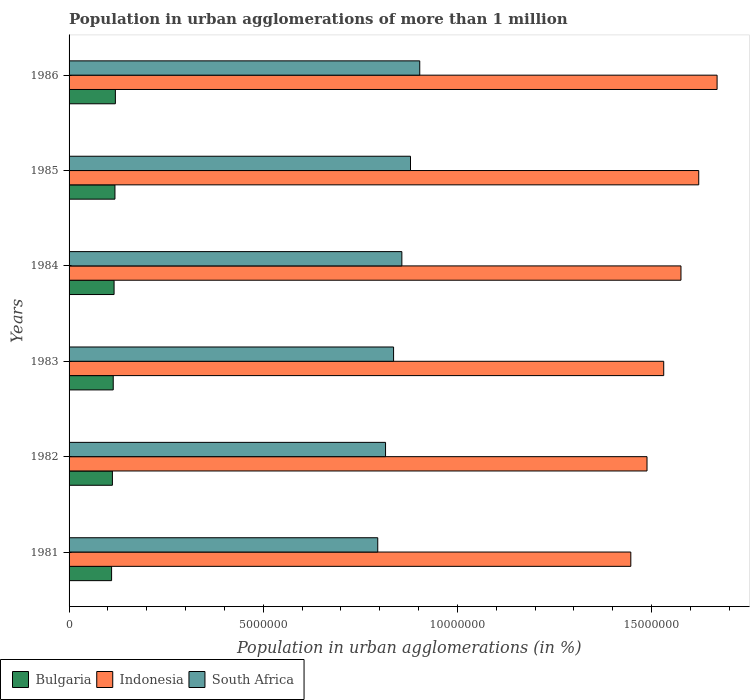How many different coloured bars are there?
Give a very brief answer. 3. Are the number of bars per tick equal to the number of legend labels?
Your answer should be compact. Yes. How many bars are there on the 1st tick from the top?
Ensure brevity in your answer.  3. What is the label of the 1st group of bars from the top?
Make the answer very short. 1986. In how many cases, is the number of bars for a given year not equal to the number of legend labels?
Provide a succinct answer. 0. What is the population in urban agglomerations in South Africa in 1982?
Offer a very short reply. 8.15e+06. Across all years, what is the maximum population in urban agglomerations in Indonesia?
Your answer should be compact. 1.67e+07. Across all years, what is the minimum population in urban agglomerations in South Africa?
Provide a short and direct response. 7.95e+06. In which year was the population in urban agglomerations in South Africa maximum?
Make the answer very short. 1986. In which year was the population in urban agglomerations in Indonesia minimum?
Offer a terse response. 1981. What is the total population in urban agglomerations in Bulgaria in the graph?
Provide a short and direct response. 6.88e+06. What is the difference between the population in urban agglomerations in South Africa in 1985 and that in 1986?
Provide a succinct answer. -2.38e+05. What is the difference between the population in urban agglomerations in South Africa in 1985 and the population in urban agglomerations in Indonesia in 1984?
Keep it short and to the point. -6.97e+06. What is the average population in urban agglomerations in South Africa per year?
Provide a succinct answer. 8.48e+06. In the year 1981, what is the difference between the population in urban agglomerations in Indonesia and population in urban agglomerations in South Africa?
Your answer should be very brief. 6.52e+06. What is the ratio of the population in urban agglomerations in Indonesia in 1982 to that in 1985?
Your answer should be compact. 0.92. Is the population in urban agglomerations in Bulgaria in 1982 less than that in 1984?
Provide a succinct answer. Yes. What is the difference between the highest and the second highest population in urban agglomerations in Indonesia?
Offer a very short reply. 4.73e+05. What is the difference between the highest and the lowest population in urban agglomerations in Bulgaria?
Your response must be concise. 9.76e+04. What does the 1st bar from the bottom in 1983 represents?
Offer a terse response. Bulgaria. Is it the case that in every year, the sum of the population in urban agglomerations in Indonesia and population in urban agglomerations in Bulgaria is greater than the population in urban agglomerations in South Africa?
Your answer should be compact. Yes. How many years are there in the graph?
Provide a succinct answer. 6. Are the values on the major ticks of X-axis written in scientific E-notation?
Ensure brevity in your answer.  No. Does the graph contain any zero values?
Make the answer very short. No. Where does the legend appear in the graph?
Provide a short and direct response. Bottom left. How many legend labels are there?
Offer a very short reply. 3. What is the title of the graph?
Provide a short and direct response. Population in urban agglomerations of more than 1 million. What is the label or title of the X-axis?
Provide a succinct answer. Population in urban agglomerations (in %). What is the Population in urban agglomerations (in %) in Bulgaria in 1981?
Your answer should be compact. 1.09e+06. What is the Population in urban agglomerations (in %) in Indonesia in 1981?
Provide a short and direct response. 1.45e+07. What is the Population in urban agglomerations (in %) of South Africa in 1981?
Your answer should be compact. 7.95e+06. What is the Population in urban agglomerations (in %) of Bulgaria in 1982?
Make the answer very short. 1.12e+06. What is the Population in urban agglomerations (in %) in Indonesia in 1982?
Offer a terse response. 1.49e+07. What is the Population in urban agglomerations (in %) of South Africa in 1982?
Offer a terse response. 8.15e+06. What is the Population in urban agglomerations (in %) of Bulgaria in 1983?
Ensure brevity in your answer.  1.14e+06. What is the Population in urban agglomerations (in %) of Indonesia in 1983?
Your answer should be compact. 1.53e+07. What is the Population in urban agglomerations (in %) of South Africa in 1983?
Give a very brief answer. 8.36e+06. What is the Population in urban agglomerations (in %) in Bulgaria in 1984?
Your answer should be compact. 1.16e+06. What is the Population in urban agglomerations (in %) of Indonesia in 1984?
Provide a succinct answer. 1.58e+07. What is the Population in urban agglomerations (in %) in South Africa in 1984?
Ensure brevity in your answer.  8.57e+06. What is the Population in urban agglomerations (in %) of Bulgaria in 1985?
Provide a short and direct response. 1.18e+06. What is the Population in urban agglomerations (in %) of Indonesia in 1985?
Offer a terse response. 1.62e+07. What is the Population in urban agglomerations (in %) of South Africa in 1985?
Give a very brief answer. 8.79e+06. What is the Population in urban agglomerations (in %) in Bulgaria in 1986?
Provide a short and direct response. 1.19e+06. What is the Population in urban agglomerations (in %) of Indonesia in 1986?
Make the answer very short. 1.67e+07. What is the Population in urban agglomerations (in %) in South Africa in 1986?
Your answer should be very brief. 9.03e+06. Across all years, what is the maximum Population in urban agglomerations (in %) in Bulgaria?
Provide a succinct answer. 1.19e+06. Across all years, what is the maximum Population in urban agglomerations (in %) of Indonesia?
Give a very brief answer. 1.67e+07. Across all years, what is the maximum Population in urban agglomerations (in %) of South Africa?
Keep it short and to the point. 9.03e+06. Across all years, what is the minimum Population in urban agglomerations (in %) of Bulgaria?
Make the answer very short. 1.09e+06. Across all years, what is the minimum Population in urban agglomerations (in %) in Indonesia?
Ensure brevity in your answer.  1.45e+07. Across all years, what is the minimum Population in urban agglomerations (in %) in South Africa?
Your answer should be compact. 7.95e+06. What is the total Population in urban agglomerations (in %) of Bulgaria in the graph?
Keep it short and to the point. 6.88e+06. What is the total Population in urban agglomerations (in %) in Indonesia in the graph?
Keep it short and to the point. 9.33e+07. What is the total Population in urban agglomerations (in %) of South Africa in the graph?
Give a very brief answer. 5.09e+07. What is the difference between the Population in urban agglomerations (in %) in Bulgaria in 1981 and that in 1982?
Keep it short and to the point. -2.10e+04. What is the difference between the Population in urban agglomerations (in %) of Indonesia in 1981 and that in 1982?
Make the answer very short. -4.17e+05. What is the difference between the Population in urban agglomerations (in %) in South Africa in 1981 and that in 1982?
Give a very brief answer. -2.01e+05. What is the difference between the Population in urban agglomerations (in %) in Bulgaria in 1981 and that in 1983?
Ensure brevity in your answer.  -4.24e+04. What is the difference between the Population in urban agglomerations (in %) in Indonesia in 1981 and that in 1983?
Provide a succinct answer. -8.47e+05. What is the difference between the Population in urban agglomerations (in %) of South Africa in 1981 and that in 1983?
Provide a short and direct response. -4.08e+05. What is the difference between the Population in urban agglomerations (in %) of Bulgaria in 1981 and that in 1984?
Offer a terse response. -6.43e+04. What is the difference between the Population in urban agglomerations (in %) in Indonesia in 1981 and that in 1984?
Provide a succinct answer. -1.29e+06. What is the difference between the Population in urban agglomerations (in %) of South Africa in 1981 and that in 1984?
Your response must be concise. -6.21e+05. What is the difference between the Population in urban agglomerations (in %) of Bulgaria in 1981 and that in 1985?
Provide a succinct answer. -8.65e+04. What is the difference between the Population in urban agglomerations (in %) in Indonesia in 1981 and that in 1985?
Provide a succinct answer. -1.75e+06. What is the difference between the Population in urban agglomerations (in %) of South Africa in 1981 and that in 1985?
Give a very brief answer. -8.44e+05. What is the difference between the Population in urban agglomerations (in %) of Bulgaria in 1981 and that in 1986?
Your response must be concise. -9.76e+04. What is the difference between the Population in urban agglomerations (in %) of Indonesia in 1981 and that in 1986?
Ensure brevity in your answer.  -2.22e+06. What is the difference between the Population in urban agglomerations (in %) of South Africa in 1981 and that in 1986?
Your answer should be very brief. -1.08e+06. What is the difference between the Population in urban agglomerations (in %) of Bulgaria in 1982 and that in 1983?
Give a very brief answer. -2.14e+04. What is the difference between the Population in urban agglomerations (in %) of Indonesia in 1982 and that in 1983?
Give a very brief answer. -4.30e+05. What is the difference between the Population in urban agglomerations (in %) in South Africa in 1982 and that in 1983?
Provide a succinct answer. -2.07e+05. What is the difference between the Population in urban agglomerations (in %) of Bulgaria in 1982 and that in 1984?
Your response must be concise. -4.33e+04. What is the difference between the Population in urban agglomerations (in %) in Indonesia in 1982 and that in 1984?
Keep it short and to the point. -8.75e+05. What is the difference between the Population in urban agglomerations (in %) of South Africa in 1982 and that in 1984?
Provide a succinct answer. -4.20e+05. What is the difference between the Population in urban agglomerations (in %) of Bulgaria in 1982 and that in 1985?
Keep it short and to the point. -6.55e+04. What is the difference between the Population in urban agglomerations (in %) of Indonesia in 1982 and that in 1985?
Your answer should be very brief. -1.33e+06. What is the difference between the Population in urban agglomerations (in %) in South Africa in 1982 and that in 1985?
Make the answer very short. -6.43e+05. What is the difference between the Population in urban agglomerations (in %) in Bulgaria in 1982 and that in 1986?
Offer a very short reply. -7.66e+04. What is the difference between the Population in urban agglomerations (in %) of Indonesia in 1982 and that in 1986?
Your answer should be compact. -1.80e+06. What is the difference between the Population in urban agglomerations (in %) in South Africa in 1982 and that in 1986?
Your answer should be compact. -8.81e+05. What is the difference between the Population in urban agglomerations (in %) in Bulgaria in 1983 and that in 1984?
Make the answer very short. -2.19e+04. What is the difference between the Population in urban agglomerations (in %) in Indonesia in 1983 and that in 1984?
Make the answer very short. -4.45e+05. What is the difference between the Population in urban agglomerations (in %) of South Africa in 1983 and that in 1984?
Provide a succinct answer. -2.13e+05. What is the difference between the Population in urban agglomerations (in %) in Bulgaria in 1983 and that in 1985?
Provide a succinct answer. -4.41e+04. What is the difference between the Population in urban agglomerations (in %) of Indonesia in 1983 and that in 1985?
Ensure brevity in your answer.  -9.02e+05. What is the difference between the Population in urban agglomerations (in %) of South Africa in 1983 and that in 1985?
Provide a succinct answer. -4.36e+05. What is the difference between the Population in urban agglomerations (in %) in Bulgaria in 1983 and that in 1986?
Your answer should be compact. -5.51e+04. What is the difference between the Population in urban agglomerations (in %) in Indonesia in 1983 and that in 1986?
Provide a succinct answer. -1.37e+06. What is the difference between the Population in urban agglomerations (in %) in South Africa in 1983 and that in 1986?
Offer a terse response. -6.74e+05. What is the difference between the Population in urban agglomerations (in %) in Bulgaria in 1984 and that in 1985?
Ensure brevity in your answer.  -2.22e+04. What is the difference between the Population in urban agglomerations (in %) in Indonesia in 1984 and that in 1985?
Your answer should be very brief. -4.57e+05. What is the difference between the Population in urban agglomerations (in %) in South Africa in 1984 and that in 1985?
Your response must be concise. -2.23e+05. What is the difference between the Population in urban agglomerations (in %) of Bulgaria in 1984 and that in 1986?
Make the answer very short. -3.33e+04. What is the difference between the Population in urban agglomerations (in %) in Indonesia in 1984 and that in 1986?
Give a very brief answer. -9.30e+05. What is the difference between the Population in urban agglomerations (in %) in South Africa in 1984 and that in 1986?
Make the answer very short. -4.61e+05. What is the difference between the Population in urban agglomerations (in %) in Bulgaria in 1985 and that in 1986?
Give a very brief answer. -1.11e+04. What is the difference between the Population in urban agglomerations (in %) of Indonesia in 1985 and that in 1986?
Your response must be concise. -4.73e+05. What is the difference between the Population in urban agglomerations (in %) in South Africa in 1985 and that in 1986?
Ensure brevity in your answer.  -2.38e+05. What is the difference between the Population in urban agglomerations (in %) of Bulgaria in 1981 and the Population in urban agglomerations (in %) of Indonesia in 1982?
Offer a terse response. -1.38e+07. What is the difference between the Population in urban agglomerations (in %) in Bulgaria in 1981 and the Population in urban agglomerations (in %) in South Africa in 1982?
Offer a very short reply. -7.06e+06. What is the difference between the Population in urban agglomerations (in %) in Indonesia in 1981 and the Population in urban agglomerations (in %) in South Africa in 1982?
Give a very brief answer. 6.32e+06. What is the difference between the Population in urban agglomerations (in %) of Bulgaria in 1981 and the Population in urban agglomerations (in %) of Indonesia in 1983?
Ensure brevity in your answer.  -1.42e+07. What is the difference between the Population in urban agglomerations (in %) of Bulgaria in 1981 and the Population in urban agglomerations (in %) of South Africa in 1983?
Your answer should be very brief. -7.26e+06. What is the difference between the Population in urban agglomerations (in %) in Indonesia in 1981 and the Population in urban agglomerations (in %) in South Africa in 1983?
Your answer should be very brief. 6.11e+06. What is the difference between the Population in urban agglomerations (in %) in Bulgaria in 1981 and the Population in urban agglomerations (in %) in Indonesia in 1984?
Provide a short and direct response. -1.47e+07. What is the difference between the Population in urban agglomerations (in %) of Bulgaria in 1981 and the Population in urban agglomerations (in %) of South Africa in 1984?
Offer a very short reply. -7.48e+06. What is the difference between the Population in urban agglomerations (in %) of Indonesia in 1981 and the Population in urban agglomerations (in %) of South Africa in 1984?
Your answer should be compact. 5.90e+06. What is the difference between the Population in urban agglomerations (in %) in Bulgaria in 1981 and the Population in urban agglomerations (in %) in Indonesia in 1985?
Make the answer very short. -1.51e+07. What is the difference between the Population in urban agglomerations (in %) of Bulgaria in 1981 and the Population in urban agglomerations (in %) of South Africa in 1985?
Give a very brief answer. -7.70e+06. What is the difference between the Population in urban agglomerations (in %) in Indonesia in 1981 and the Population in urban agglomerations (in %) in South Africa in 1985?
Your answer should be very brief. 5.67e+06. What is the difference between the Population in urban agglomerations (in %) of Bulgaria in 1981 and the Population in urban agglomerations (in %) of Indonesia in 1986?
Offer a terse response. -1.56e+07. What is the difference between the Population in urban agglomerations (in %) of Bulgaria in 1981 and the Population in urban agglomerations (in %) of South Africa in 1986?
Your response must be concise. -7.94e+06. What is the difference between the Population in urban agglomerations (in %) of Indonesia in 1981 and the Population in urban agglomerations (in %) of South Africa in 1986?
Offer a terse response. 5.44e+06. What is the difference between the Population in urban agglomerations (in %) of Bulgaria in 1982 and the Population in urban agglomerations (in %) of Indonesia in 1983?
Ensure brevity in your answer.  -1.42e+07. What is the difference between the Population in urban agglomerations (in %) in Bulgaria in 1982 and the Population in urban agglomerations (in %) in South Africa in 1983?
Provide a short and direct response. -7.24e+06. What is the difference between the Population in urban agglomerations (in %) in Indonesia in 1982 and the Population in urban agglomerations (in %) in South Africa in 1983?
Your answer should be very brief. 6.53e+06. What is the difference between the Population in urban agglomerations (in %) of Bulgaria in 1982 and the Population in urban agglomerations (in %) of Indonesia in 1984?
Make the answer very short. -1.46e+07. What is the difference between the Population in urban agglomerations (in %) of Bulgaria in 1982 and the Population in urban agglomerations (in %) of South Africa in 1984?
Provide a short and direct response. -7.45e+06. What is the difference between the Population in urban agglomerations (in %) of Indonesia in 1982 and the Population in urban agglomerations (in %) of South Africa in 1984?
Give a very brief answer. 6.31e+06. What is the difference between the Population in urban agglomerations (in %) of Bulgaria in 1982 and the Population in urban agglomerations (in %) of Indonesia in 1985?
Give a very brief answer. -1.51e+07. What is the difference between the Population in urban agglomerations (in %) in Bulgaria in 1982 and the Population in urban agglomerations (in %) in South Africa in 1985?
Give a very brief answer. -7.68e+06. What is the difference between the Population in urban agglomerations (in %) of Indonesia in 1982 and the Population in urban agglomerations (in %) of South Africa in 1985?
Keep it short and to the point. 6.09e+06. What is the difference between the Population in urban agglomerations (in %) in Bulgaria in 1982 and the Population in urban agglomerations (in %) in Indonesia in 1986?
Provide a short and direct response. -1.56e+07. What is the difference between the Population in urban agglomerations (in %) in Bulgaria in 1982 and the Population in urban agglomerations (in %) in South Africa in 1986?
Offer a very short reply. -7.92e+06. What is the difference between the Population in urban agglomerations (in %) of Indonesia in 1982 and the Population in urban agglomerations (in %) of South Africa in 1986?
Make the answer very short. 5.85e+06. What is the difference between the Population in urban agglomerations (in %) in Bulgaria in 1983 and the Population in urban agglomerations (in %) in Indonesia in 1984?
Your response must be concise. -1.46e+07. What is the difference between the Population in urban agglomerations (in %) in Bulgaria in 1983 and the Population in urban agglomerations (in %) in South Africa in 1984?
Your response must be concise. -7.43e+06. What is the difference between the Population in urban agglomerations (in %) of Indonesia in 1983 and the Population in urban agglomerations (in %) of South Africa in 1984?
Offer a very short reply. 6.74e+06. What is the difference between the Population in urban agglomerations (in %) in Bulgaria in 1983 and the Population in urban agglomerations (in %) in Indonesia in 1985?
Your answer should be very brief. -1.51e+07. What is the difference between the Population in urban agglomerations (in %) of Bulgaria in 1983 and the Population in urban agglomerations (in %) of South Africa in 1985?
Provide a succinct answer. -7.66e+06. What is the difference between the Population in urban agglomerations (in %) in Indonesia in 1983 and the Population in urban agglomerations (in %) in South Africa in 1985?
Your answer should be very brief. 6.52e+06. What is the difference between the Population in urban agglomerations (in %) in Bulgaria in 1983 and the Population in urban agglomerations (in %) in Indonesia in 1986?
Your answer should be very brief. -1.56e+07. What is the difference between the Population in urban agglomerations (in %) of Bulgaria in 1983 and the Population in urban agglomerations (in %) of South Africa in 1986?
Your answer should be compact. -7.89e+06. What is the difference between the Population in urban agglomerations (in %) of Indonesia in 1983 and the Population in urban agglomerations (in %) of South Africa in 1986?
Provide a short and direct response. 6.28e+06. What is the difference between the Population in urban agglomerations (in %) in Bulgaria in 1984 and the Population in urban agglomerations (in %) in Indonesia in 1985?
Make the answer very short. -1.51e+07. What is the difference between the Population in urban agglomerations (in %) of Bulgaria in 1984 and the Population in urban agglomerations (in %) of South Africa in 1985?
Your answer should be very brief. -7.63e+06. What is the difference between the Population in urban agglomerations (in %) in Indonesia in 1984 and the Population in urban agglomerations (in %) in South Africa in 1985?
Ensure brevity in your answer.  6.97e+06. What is the difference between the Population in urban agglomerations (in %) of Bulgaria in 1984 and the Population in urban agglomerations (in %) of Indonesia in 1986?
Make the answer very short. -1.55e+07. What is the difference between the Population in urban agglomerations (in %) of Bulgaria in 1984 and the Population in urban agglomerations (in %) of South Africa in 1986?
Give a very brief answer. -7.87e+06. What is the difference between the Population in urban agglomerations (in %) of Indonesia in 1984 and the Population in urban agglomerations (in %) of South Africa in 1986?
Provide a short and direct response. 6.73e+06. What is the difference between the Population in urban agglomerations (in %) of Bulgaria in 1985 and the Population in urban agglomerations (in %) of Indonesia in 1986?
Ensure brevity in your answer.  -1.55e+07. What is the difference between the Population in urban agglomerations (in %) in Bulgaria in 1985 and the Population in urban agglomerations (in %) in South Africa in 1986?
Provide a short and direct response. -7.85e+06. What is the difference between the Population in urban agglomerations (in %) of Indonesia in 1985 and the Population in urban agglomerations (in %) of South Africa in 1986?
Offer a very short reply. 7.18e+06. What is the average Population in urban agglomerations (in %) of Bulgaria per year?
Ensure brevity in your answer.  1.15e+06. What is the average Population in urban agglomerations (in %) of Indonesia per year?
Provide a short and direct response. 1.56e+07. What is the average Population in urban agglomerations (in %) of South Africa per year?
Ensure brevity in your answer.  8.48e+06. In the year 1981, what is the difference between the Population in urban agglomerations (in %) of Bulgaria and Population in urban agglomerations (in %) of Indonesia?
Keep it short and to the point. -1.34e+07. In the year 1981, what is the difference between the Population in urban agglomerations (in %) of Bulgaria and Population in urban agglomerations (in %) of South Africa?
Provide a succinct answer. -6.85e+06. In the year 1981, what is the difference between the Population in urban agglomerations (in %) of Indonesia and Population in urban agglomerations (in %) of South Africa?
Your response must be concise. 6.52e+06. In the year 1982, what is the difference between the Population in urban agglomerations (in %) in Bulgaria and Population in urban agglomerations (in %) in Indonesia?
Provide a short and direct response. -1.38e+07. In the year 1982, what is the difference between the Population in urban agglomerations (in %) of Bulgaria and Population in urban agglomerations (in %) of South Africa?
Your answer should be very brief. -7.03e+06. In the year 1982, what is the difference between the Population in urban agglomerations (in %) of Indonesia and Population in urban agglomerations (in %) of South Africa?
Keep it short and to the point. 6.73e+06. In the year 1983, what is the difference between the Population in urban agglomerations (in %) of Bulgaria and Population in urban agglomerations (in %) of Indonesia?
Ensure brevity in your answer.  -1.42e+07. In the year 1983, what is the difference between the Population in urban agglomerations (in %) of Bulgaria and Population in urban agglomerations (in %) of South Africa?
Give a very brief answer. -7.22e+06. In the year 1983, what is the difference between the Population in urban agglomerations (in %) of Indonesia and Population in urban agglomerations (in %) of South Africa?
Make the answer very short. 6.96e+06. In the year 1984, what is the difference between the Population in urban agglomerations (in %) in Bulgaria and Population in urban agglomerations (in %) in Indonesia?
Provide a succinct answer. -1.46e+07. In the year 1984, what is the difference between the Population in urban agglomerations (in %) of Bulgaria and Population in urban agglomerations (in %) of South Africa?
Offer a very short reply. -7.41e+06. In the year 1984, what is the difference between the Population in urban agglomerations (in %) of Indonesia and Population in urban agglomerations (in %) of South Africa?
Offer a terse response. 7.19e+06. In the year 1985, what is the difference between the Population in urban agglomerations (in %) of Bulgaria and Population in urban agglomerations (in %) of Indonesia?
Make the answer very short. -1.50e+07. In the year 1985, what is the difference between the Population in urban agglomerations (in %) of Bulgaria and Population in urban agglomerations (in %) of South Africa?
Keep it short and to the point. -7.61e+06. In the year 1985, what is the difference between the Population in urban agglomerations (in %) of Indonesia and Population in urban agglomerations (in %) of South Africa?
Your answer should be very brief. 7.42e+06. In the year 1986, what is the difference between the Population in urban agglomerations (in %) of Bulgaria and Population in urban agglomerations (in %) of Indonesia?
Your response must be concise. -1.55e+07. In the year 1986, what is the difference between the Population in urban agglomerations (in %) of Bulgaria and Population in urban agglomerations (in %) of South Africa?
Offer a terse response. -7.84e+06. In the year 1986, what is the difference between the Population in urban agglomerations (in %) in Indonesia and Population in urban agglomerations (in %) in South Africa?
Your answer should be very brief. 7.66e+06. What is the ratio of the Population in urban agglomerations (in %) in Bulgaria in 1981 to that in 1982?
Provide a succinct answer. 0.98. What is the ratio of the Population in urban agglomerations (in %) in Indonesia in 1981 to that in 1982?
Ensure brevity in your answer.  0.97. What is the ratio of the Population in urban agglomerations (in %) of South Africa in 1981 to that in 1982?
Your response must be concise. 0.98. What is the ratio of the Population in urban agglomerations (in %) of Bulgaria in 1981 to that in 1983?
Your response must be concise. 0.96. What is the ratio of the Population in urban agglomerations (in %) of Indonesia in 1981 to that in 1983?
Your response must be concise. 0.94. What is the ratio of the Population in urban agglomerations (in %) in South Africa in 1981 to that in 1983?
Your response must be concise. 0.95. What is the ratio of the Population in urban agglomerations (in %) in Bulgaria in 1981 to that in 1984?
Offer a terse response. 0.94. What is the ratio of the Population in urban agglomerations (in %) in Indonesia in 1981 to that in 1984?
Offer a terse response. 0.92. What is the ratio of the Population in urban agglomerations (in %) of South Africa in 1981 to that in 1984?
Make the answer very short. 0.93. What is the ratio of the Population in urban agglomerations (in %) of Bulgaria in 1981 to that in 1985?
Provide a succinct answer. 0.93. What is the ratio of the Population in urban agglomerations (in %) in Indonesia in 1981 to that in 1985?
Keep it short and to the point. 0.89. What is the ratio of the Population in urban agglomerations (in %) of South Africa in 1981 to that in 1985?
Your response must be concise. 0.9. What is the ratio of the Population in urban agglomerations (in %) in Bulgaria in 1981 to that in 1986?
Keep it short and to the point. 0.92. What is the ratio of the Population in urban agglomerations (in %) of Indonesia in 1981 to that in 1986?
Keep it short and to the point. 0.87. What is the ratio of the Population in urban agglomerations (in %) of South Africa in 1981 to that in 1986?
Ensure brevity in your answer.  0.88. What is the ratio of the Population in urban agglomerations (in %) in Bulgaria in 1982 to that in 1983?
Provide a short and direct response. 0.98. What is the ratio of the Population in urban agglomerations (in %) of Indonesia in 1982 to that in 1983?
Your answer should be compact. 0.97. What is the ratio of the Population in urban agglomerations (in %) in South Africa in 1982 to that in 1983?
Give a very brief answer. 0.98. What is the ratio of the Population in urban agglomerations (in %) of Bulgaria in 1982 to that in 1984?
Give a very brief answer. 0.96. What is the ratio of the Population in urban agglomerations (in %) in Indonesia in 1982 to that in 1984?
Make the answer very short. 0.94. What is the ratio of the Population in urban agglomerations (in %) in South Africa in 1982 to that in 1984?
Your answer should be very brief. 0.95. What is the ratio of the Population in urban agglomerations (in %) of Bulgaria in 1982 to that in 1985?
Your answer should be very brief. 0.94. What is the ratio of the Population in urban agglomerations (in %) of Indonesia in 1982 to that in 1985?
Make the answer very short. 0.92. What is the ratio of the Population in urban agglomerations (in %) in South Africa in 1982 to that in 1985?
Offer a very short reply. 0.93. What is the ratio of the Population in urban agglomerations (in %) in Bulgaria in 1982 to that in 1986?
Offer a terse response. 0.94. What is the ratio of the Population in urban agglomerations (in %) in Indonesia in 1982 to that in 1986?
Your answer should be very brief. 0.89. What is the ratio of the Population in urban agglomerations (in %) of South Africa in 1982 to that in 1986?
Make the answer very short. 0.9. What is the ratio of the Population in urban agglomerations (in %) of Bulgaria in 1983 to that in 1984?
Offer a terse response. 0.98. What is the ratio of the Population in urban agglomerations (in %) of Indonesia in 1983 to that in 1984?
Make the answer very short. 0.97. What is the ratio of the Population in urban agglomerations (in %) of South Africa in 1983 to that in 1984?
Make the answer very short. 0.98. What is the ratio of the Population in urban agglomerations (in %) in Bulgaria in 1983 to that in 1985?
Your response must be concise. 0.96. What is the ratio of the Population in urban agglomerations (in %) of South Africa in 1983 to that in 1985?
Keep it short and to the point. 0.95. What is the ratio of the Population in urban agglomerations (in %) of Bulgaria in 1983 to that in 1986?
Ensure brevity in your answer.  0.95. What is the ratio of the Population in urban agglomerations (in %) of Indonesia in 1983 to that in 1986?
Provide a succinct answer. 0.92. What is the ratio of the Population in urban agglomerations (in %) in South Africa in 1983 to that in 1986?
Your answer should be very brief. 0.93. What is the ratio of the Population in urban agglomerations (in %) in Bulgaria in 1984 to that in 1985?
Give a very brief answer. 0.98. What is the ratio of the Population in urban agglomerations (in %) in Indonesia in 1984 to that in 1985?
Offer a very short reply. 0.97. What is the ratio of the Population in urban agglomerations (in %) in South Africa in 1984 to that in 1985?
Keep it short and to the point. 0.97. What is the ratio of the Population in urban agglomerations (in %) in Bulgaria in 1984 to that in 1986?
Keep it short and to the point. 0.97. What is the ratio of the Population in urban agglomerations (in %) of Indonesia in 1984 to that in 1986?
Keep it short and to the point. 0.94. What is the ratio of the Population in urban agglomerations (in %) of South Africa in 1984 to that in 1986?
Your answer should be very brief. 0.95. What is the ratio of the Population in urban agglomerations (in %) in Bulgaria in 1985 to that in 1986?
Your answer should be very brief. 0.99. What is the ratio of the Population in urban agglomerations (in %) of Indonesia in 1985 to that in 1986?
Your answer should be very brief. 0.97. What is the ratio of the Population in urban agglomerations (in %) of South Africa in 1985 to that in 1986?
Make the answer very short. 0.97. What is the difference between the highest and the second highest Population in urban agglomerations (in %) of Bulgaria?
Keep it short and to the point. 1.11e+04. What is the difference between the highest and the second highest Population in urban agglomerations (in %) of Indonesia?
Give a very brief answer. 4.73e+05. What is the difference between the highest and the second highest Population in urban agglomerations (in %) of South Africa?
Ensure brevity in your answer.  2.38e+05. What is the difference between the highest and the lowest Population in urban agglomerations (in %) of Bulgaria?
Your response must be concise. 9.76e+04. What is the difference between the highest and the lowest Population in urban agglomerations (in %) in Indonesia?
Provide a succinct answer. 2.22e+06. What is the difference between the highest and the lowest Population in urban agglomerations (in %) in South Africa?
Ensure brevity in your answer.  1.08e+06. 